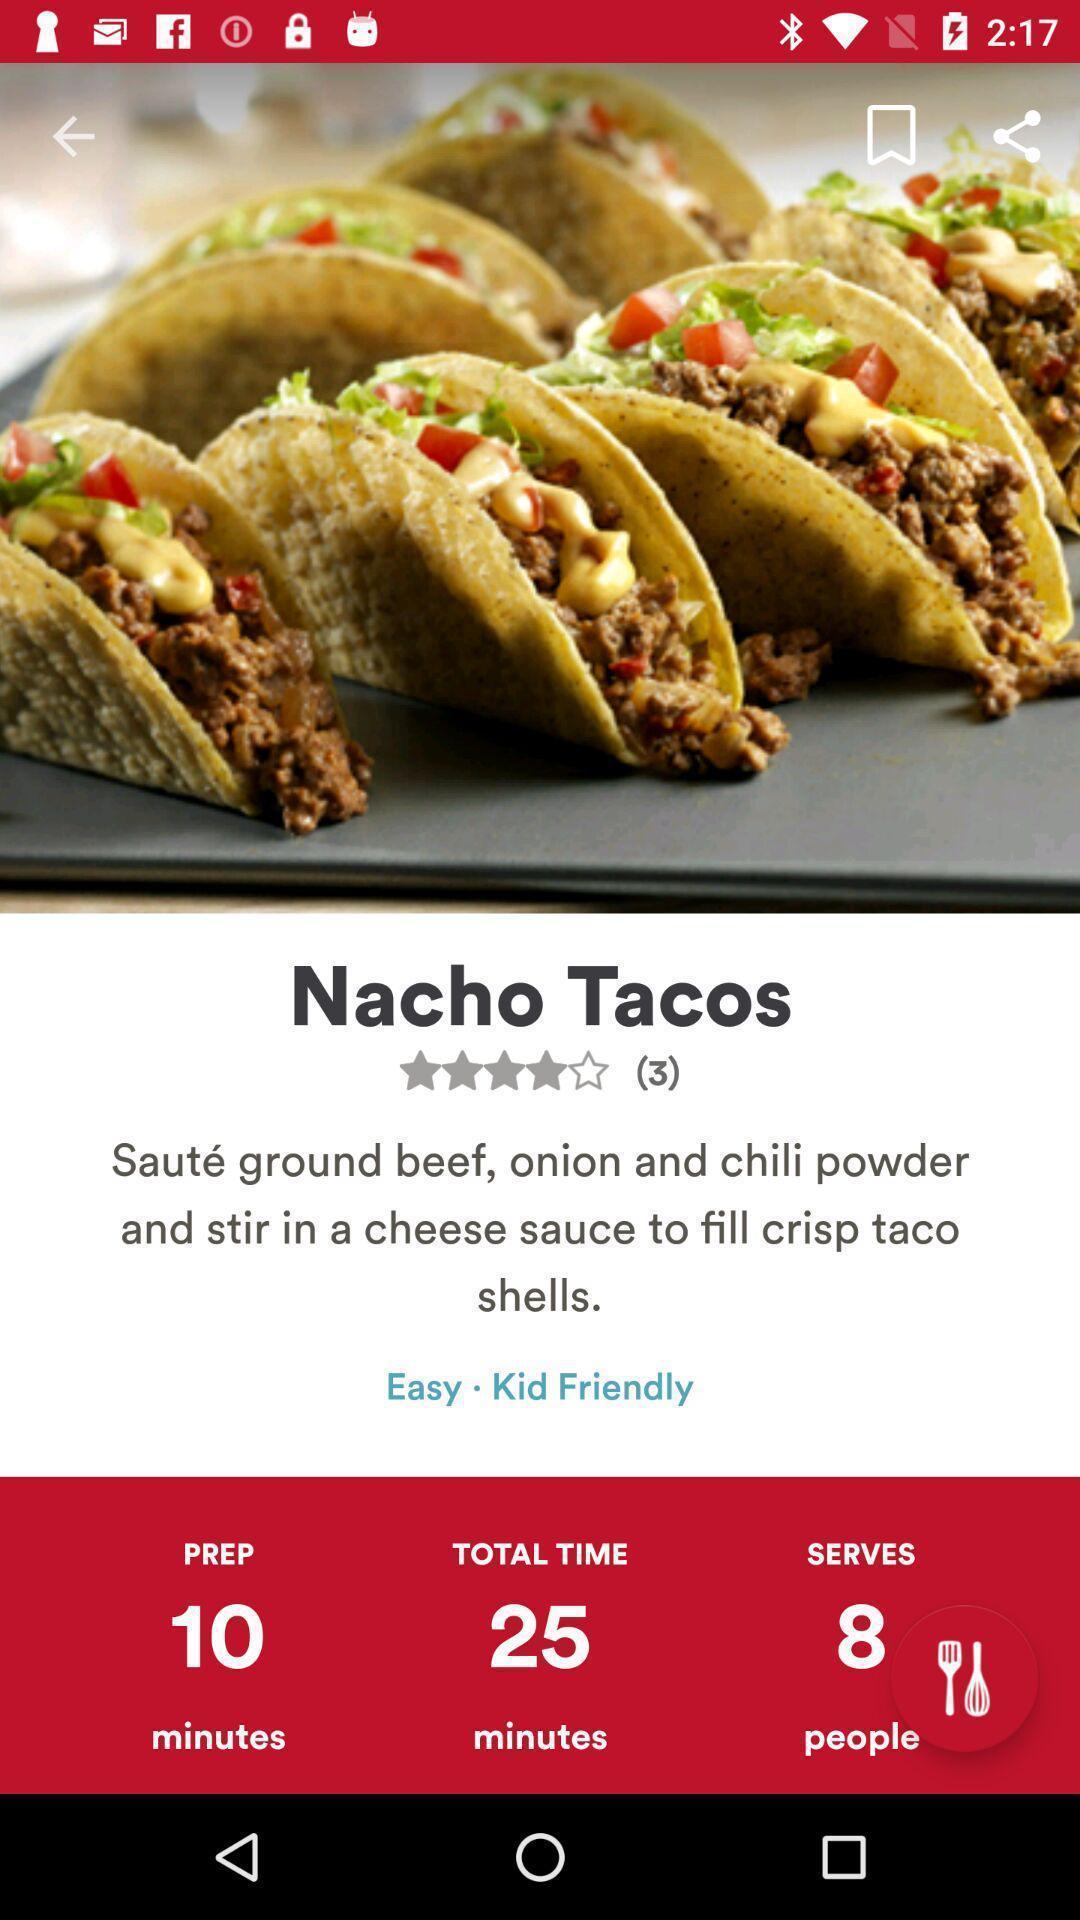Please provide a description for this image. Page showing food recipe with details. 